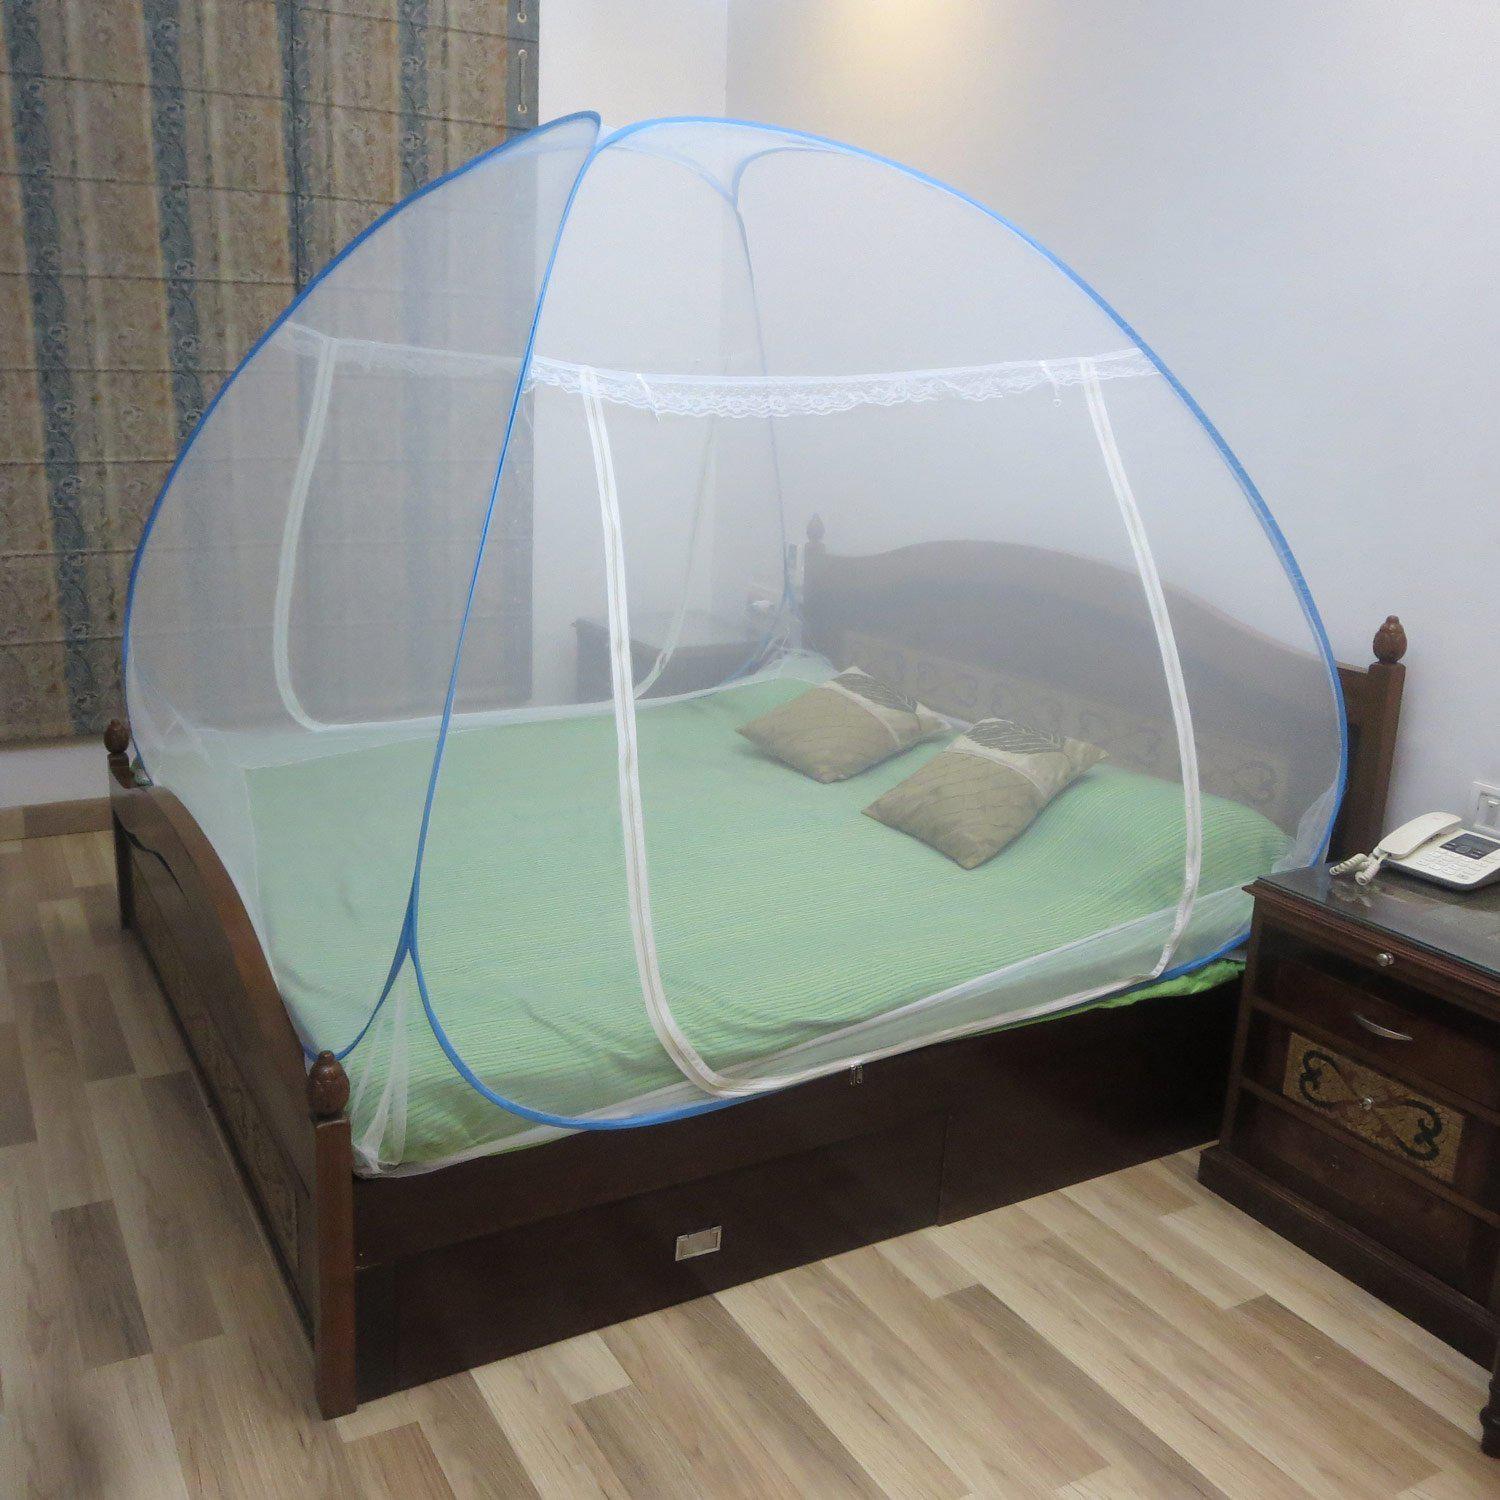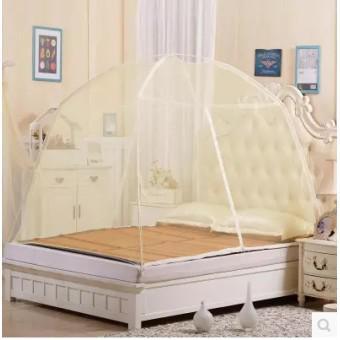The first image is the image on the left, the second image is the image on the right. Assess this claim about the two images: "Beds are draped in a gauzy material that hangs from a central point in the ceiling over each bed.". Correct or not? Answer yes or no. No. 